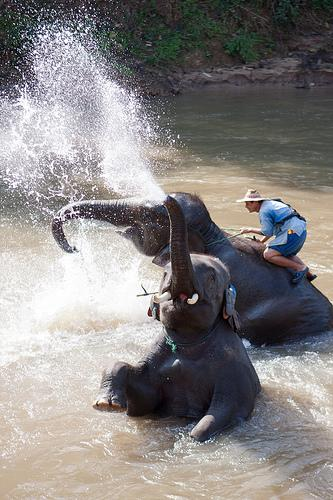Explain what is happening in the image in a poetic language. Beneath sapphire skies, majestic gray elephants frolic in swirling brown waters, while a man in azure attire perches upon one gentle giant, basking in the beauty of their riverside dance. How many elephants are in the image and what color are they? There are two elephants, and they are gray in color. How is the man on the elephant's back interacting with the water, if at all? The man is not directly interacting with the water, but he is hanging onto a rope attached to the elephant. What are the significant differences between the two elephants in terms of their activities? One elephant is shooting water out of its trunk while the other one has a man riding on its back. Mention three objects or entities interacting in the image. The man, the elephant he is riding, and the water. What are the primary colors observed in the image? Gray, brown, blue, and green. Provide a brief description of the scene in the image. Two elephants are playing in the water, with one squirting water through its trunk and a man riding on the back of the other, while wearing a tan hat and blue clothes. Describe the setting of the image based on the colors, vegetation, and terrain. The image takes place in a riverside area with brown water, rocky mud terrain, green plant life, and bushes. Identify the color of the man's attire and the type of hat he is wearing. The man is wearing a blue shirt, blue shorts, and a tan hat. Using casual language, describe the activities taking place in the image. Two elephants are just chilling in the water, having a blast. One is splashing water with its trunk, and a dude is riding the other one, all decked out in blue and a cool hat. Describe the main actions taking place in this image. A man is riding an elephant, and an elephant is squirting water out of its trunk in the river. Please focus on a red boat floating in the far background of the river. How does it look compared to the size of the elephants? No, it's not mentioned in the image. Name the color and state of the elephant's hooves. The hooves are tan. Provide a caption for this scene using a poetic style. Beside the flowing river's bend, a man aloft the elephant, they share their playful moments' end. Identify and describe the plants in the image. There are green bushes near the riverside. Explain the color and state of the water in this image. The water is brown and has ripples. What color are the tusks of the elephants? White Describe the location where the image takes place. The image takes place at a riverside with rocky land and green plant life on the terrain. Provide a brief description of the man's outfit on the elephant. He is wearing a tan hat, a blue shirt, blue shorts, and blue shoes. Based on the details in the image, tell me what's happening close to the water? Elephants are playing in the water and one is splashing water with its trunk. Judging by the provided information, can you determine what the weather may be like? Cannot determine from the provided information. Which of the following descriptions best fits the scene: A) Two elephants playing in a field B) A man riding an elephant near a river C) A group of people at a party? B) A man riding an elephant near a river Based on the image, how many elephants are present? Two What color are the shoes of the man riding the elephant? Blue Describe the rope that the man is holding onto. It is a rope that the man uses to hang onto the elephant. What does the terrain next to the water look like? The terrain is rocky with green plant life. 